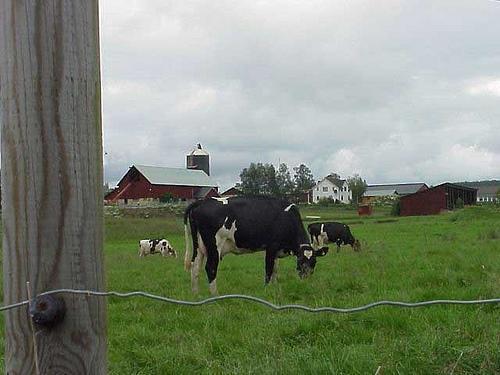How many cows are there?
Give a very brief answer. 3. 